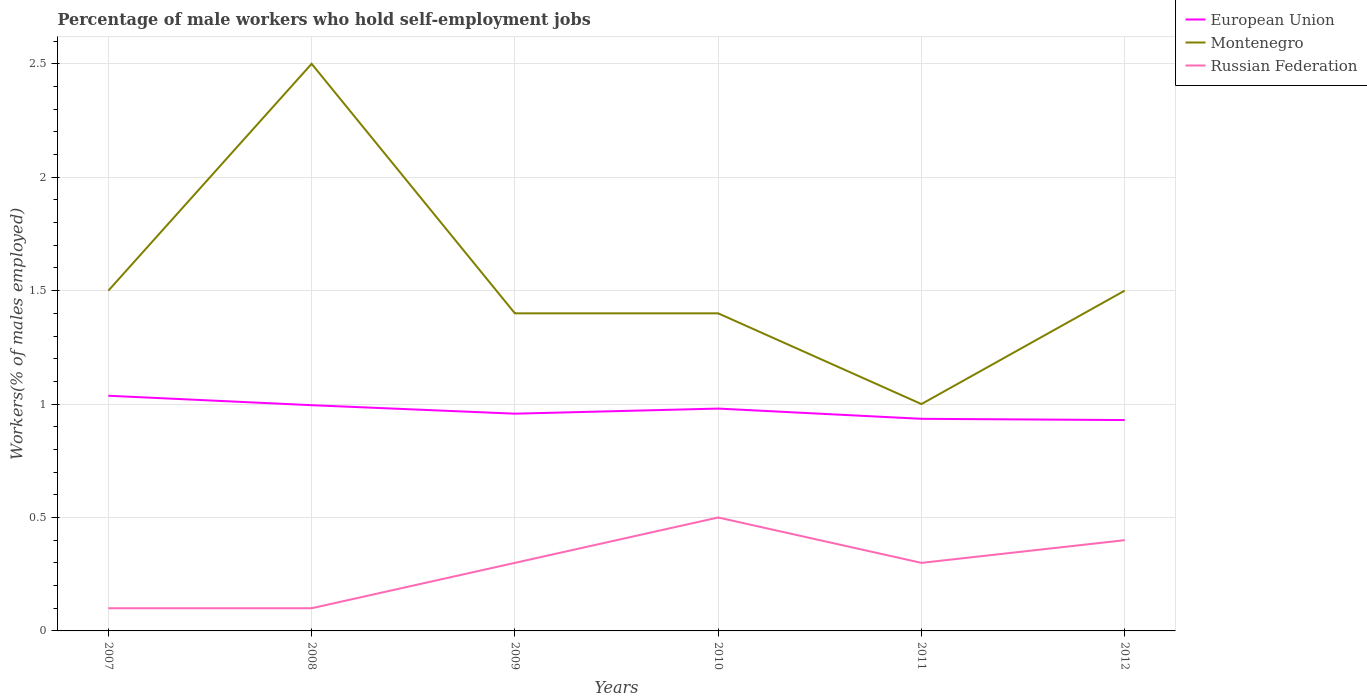How many different coloured lines are there?
Provide a succinct answer. 3. Is the number of lines equal to the number of legend labels?
Provide a short and direct response. Yes. Across all years, what is the maximum percentage of self-employed male workers in European Union?
Provide a succinct answer. 0.93. What is the total percentage of self-employed male workers in European Union in the graph?
Keep it short and to the point. 0.1. What is the difference between the highest and the second highest percentage of self-employed male workers in Russian Federation?
Offer a terse response. 0.4. What is the difference between the highest and the lowest percentage of self-employed male workers in European Union?
Offer a terse response. 3. How many lines are there?
Offer a terse response. 3. How many years are there in the graph?
Ensure brevity in your answer.  6. What is the difference between two consecutive major ticks on the Y-axis?
Ensure brevity in your answer.  0.5. Does the graph contain grids?
Keep it short and to the point. Yes. Where does the legend appear in the graph?
Keep it short and to the point. Top right. How many legend labels are there?
Provide a succinct answer. 3. What is the title of the graph?
Your answer should be very brief. Percentage of male workers who hold self-employment jobs. Does "Heavily indebted poor countries" appear as one of the legend labels in the graph?
Keep it short and to the point. No. What is the label or title of the Y-axis?
Your answer should be very brief. Workers(% of males employed). What is the Workers(% of males employed) in European Union in 2007?
Offer a terse response. 1.04. What is the Workers(% of males employed) of Montenegro in 2007?
Your answer should be very brief. 1.5. What is the Workers(% of males employed) in Russian Federation in 2007?
Provide a short and direct response. 0.1. What is the Workers(% of males employed) in European Union in 2008?
Give a very brief answer. 1. What is the Workers(% of males employed) of Russian Federation in 2008?
Offer a very short reply. 0.1. What is the Workers(% of males employed) in European Union in 2009?
Make the answer very short. 0.96. What is the Workers(% of males employed) in Montenegro in 2009?
Give a very brief answer. 1.4. What is the Workers(% of males employed) in Russian Federation in 2009?
Your response must be concise. 0.3. What is the Workers(% of males employed) of European Union in 2010?
Your answer should be compact. 0.98. What is the Workers(% of males employed) in Montenegro in 2010?
Provide a succinct answer. 1.4. What is the Workers(% of males employed) of Russian Federation in 2010?
Your response must be concise. 0.5. What is the Workers(% of males employed) in European Union in 2011?
Provide a succinct answer. 0.94. What is the Workers(% of males employed) in Montenegro in 2011?
Ensure brevity in your answer.  1. What is the Workers(% of males employed) in Russian Federation in 2011?
Give a very brief answer. 0.3. What is the Workers(% of males employed) in European Union in 2012?
Keep it short and to the point. 0.93. What is the Workers(% of males employed) of Montenegro in 2012?
Keep it short and to the point. 1.5. What is the Workers(% of males employed) in Russian Federation in 2012?
Give a very brief answer. 0.4. Across all years, what is the maximum Workers(% of males employed) in European Union?
Provide a succinct answer. 1.04. Across all years, what is the maximum Workers(% of males employed) of Russian Federation?
Provide a short and direct response. 0.5. Across all years, what is the minimum Workers(% of males employed) in European Union?
Your answer should be very brief. 0.93. Across all years, what is the minimum Workers(% of males employed) of Russian Federation?
Your answer should be very brief. 0.1. What is the total Workers(% of males employed) in European Union in the graph?
Your answer should be compact. 5.83. What is the total Workers(% of males employed) in Montenegro in the graph?
Provide a short and direct response. 9.3. What is the total Workers(% of males employed) of Russian Federation in the graph?
Give a very brief answer. 1.7. What is the difference between the Workers(% of males employed) in European Union in 2007 and that in 2008?
Keep it short and to the point. 0.04. What is the difference between the Workers(% of males employed) in Montenegro in 2007 and that in 2008?
Give a very brief answer. -1. What is the difference between the Workers(% of males employed) in Russian Federation in 2007 and that in 2008?
Your answer should be compact. 0. What is the difference between the Workers(% of males employed) in European Union in 2007 and that in 2009?
Give a very brief answer. 0.08. What is the difference between the Workers(% of males employed) of Montenegro in 2007 and that in 2009?
Offer a very short reply. 0.1. What is the difference between the Workers(% of males employed) in Russian Federation in 2007 and that in 2009?
Give a very brief answer. -0.2. What is the difference between the Workers(% of males employed) of European Union in 2007 and that in 2010?
Make the answer very short. 0.06. What is the difference between the Workers(% of males employed) of Russian Federation in 2007 and that in 2010?
Offer a very short reply. -0.4. What is the difference between the Workers(% of males employed) in European Union in 2007 and that in 2011?
Offer a very short reply. 0.1. What is the difference between the Workers(% of males employed) in European Union in 2007 and that in 2012?
Make the answer very short. 0.11. What is the difference between the Workers(% of males employed) of Montenegro in 2007 and that in 2012?
Offer a terse response. 0. What is the difference between the Workers(% of males employed) in Russian Federation in 2007 and that in 2012?
Give a very brief answer. -0.3. What is the difference between the Workers(% of males employed) of European Union in 2008 and that in 2009?
Make the answer very short. 0.04. What is the difference between the Workers(% of males employed) of Montenegro in 2008 and that in 2009?
Ensure brevity in your answer.  1.1. What is the difference between the Workers(% of males employed) in Russian Federation in 2008 and that in 2009?
Provide a succinct answer. -0.2. What is the difference between the Workers(% of males employed) of European Union in 2008 and that in 2010?
Your answer should be compact. 0.01. What is the difference between the Workers(% of males employed) of Montenegro in 2008 and that in 2010?
Offer a terse response. 1.1. What is the difference between the Workers(% of males employed) in European Union in 2008 and that in 2011?
Your answer should be compact. 0.06. What is the difference between the Workers(% of males employed) in Russian Federation in 2008 and that in 2011?
Provide a short and direct response. -0.2. What is the difference between the Workers(% of males employed) of European Union in 2008 and that in 2012?
Your response must be concise. 0.07. What is the difference between the Workers(% of males employed) of European Union in 2009 and that in 2010?
Offer a terse response. -0.02. What is the difference between the Workers(% of males employed) in Montenegro in 2009 and that in 2010?
Your response must be concise. 0. What is the difference between the Workers(% of males employed) of European Union in 2009 and that in 2011?
Your response must be concise. 0.02. What is the difference between the Workers(% of males employed) of Russian Federation in 2009 and that in 2011?
Give a very brief answer. 0. What is the difference between the Workers(% of males employed) in European Union in 2009 and that in 2012?
Your answer should be compact. 0.03. What is the difference between the Workers(% of males employed) of Montenegro in 2009 and that in 2012?
Your response must be concise. -0.1. What is the difference between the Workers(% of males employed) of European Union in 2010 and that in 2011?
Offer a very short reply. 0.05. What is the difference between the Workers(% of males employed) in Montenegro in 2010 and that in 2011?
Ensure brevity in your answer.  0.4. What is the difference between the Workers(% of males employed) in Russian Federation in 2010 and that in 2011?
Your answer should be compact. 0.2. What is the difference between the Workers(% of males employed) in European Union in 2010 and that in 2012?
Give a very brief answer. 0.05. What is the difference between the Workers(% of males employed) of Montenegro in 2010 and that in 2012?
Provide a short and direct response. -0.1. What is the difference between the Workers(% of males employed) in Russian Federation in 2010 and that in 2012?
Offer a terse response. 0.1. What is the difference between the Workers(% of males employed) in European Union in 2011 and that in 2012?
Offer a very short reply. 0.01. What is the difference between the Workers(% of males employed) of European Union in 2007 and the Workers(% of males employed) of Montenegro in 2008?
Your answer should be very brief. -1.46. What is the difference between the Workers(% of males employed) in European Union in 2007 and the Workers(% of males employed) in Russian Federation in 2008?
Keep it short and to the point. 0.94. What is the difference between the Workers(% of males employed) of European Union in 2007 and the Workers(% of males employed) of Montenegro in 2009?
Give a very brief answer. -0.36. What is the difference between the Workers(% of males employed) of European Union in 2007 and the Workers(% of males employed) of Russian Federation in 2009?
Ensure brevity in your answer.  0.74. What is the difference between the Workers(% of males employed) of European Union in 2007 and the Workers(% of males employed) of Montenegro in 2010?
Ensure brevity in your answer.  -0.36. What is the difference between the Workers(% of males employed) of European Union in 2007 and the Workers(% of males employed) of Russian Federation in 2010?
Make the answer very short. 0.54. What is the difference between the Workers(% of males employed) in European Union in 2007 and the Workers(% of males employed) in Montenegro in 2011?
Provide a succinct answer. 0.04. What is the difference between the Workers(% of males employed) in European Union in 2007 and the Workers(% of males employed) in Russian Federation in 2011?
Keep it short and to the point. 0.74. What is the difference between the Workers(% of males employed) of European Union in 2007 and the Workers(% of males employed) of Montenegro in 2012?
Your answer should be very brief. -0.46. What is the difference between the Workers(% of males employed) in European Union in 2007 and the Workers(% of males employed) in Russian Federation in 2012?
Your answer should be compact. 0.64. What is the difference between the Workers(% of males employed) of European Union in 2008 and the Workers(% of males employed) of Montenegro in 2009?
Offer a very short reply. -0.4. What is the difference between the Workers(% of males employed) of European Union in 2008 and the Workers(% of males employed) of Russian Federation in 2009?
Provide a short and direct response. 0.7. What is the difference between the Workers(% of males employed) in Montenegro in 2008 and the Workers(% of males employed) in Russian Federation in 2009?
Your response must be concise. 2.2. What is the difference between the Workers(% of males employed) of European Union in 2008 and the Workers(% of males employed) of Montenegro in 2010?
Ensure brevity in your answer.  -0.4. What is the difference between the Workers(% of males employed) in European Union in 2008 and the Workers(% of males employed) in Russian Federation in 2010?
Provide a succinct answer. 0.5. What is the difference between the Workers(% of males employed) in Montenegro in 2008 and the Workers(% of males employed) in Russian Federation in 2010?
Offer a very short reply. 2. What is the difference between the Workers(% of males employed) in European Union in 2008 and the Workers(% of males employed) in Montenegro in 2011?
Ensure brevity in your answer.  -0. What is the difference between the Workers(% of males employed) of European Union in 2008 and the Workers(% of males employed) of Russian Federation in 2011?
Ensure brevity in your answer.  0.7. What is the difference between the Workers(% of males employed) in European Union in 2008 and the Workers(% of males employed) in Montenegro in 2012?
Your answer should be compact. -0.5. What is the difference between the Workers(% of males employed) of European Union in 2008 and the Workers(% of males employed) of Russian Federation in 2012?
Ensure brevity in your answer.  0.6. What is the difference between the Workers(% of males employed) in Montenegro in 2008 and the Workers(% of males employed) in Russian Federation in 2012?
Make the answer very short. 2.1. What is the difference between the Workers(% of males employed) in European Union in 2009 and the Workers(% of males employed) in Montenegro in 2010?
Offer a very short reply. -0.44. What is the difference between the Workers(% of males employed) of European Union in 2009 and the Workers(% of males employed) of Russian Federation in 2010?
Your answer should be very brief. 0.46. What is the difference between the Workers(% of males employed) of Montenegro in 2009 and the Workers(% of males employed) of Russian Federation in 2010?
Your answer should be very brief. 0.9. What is the difference between the Workers(% of males employed) in European Union in 2009 and the Workers(% of males employed) in Montenegro in 2011?
Provide a succinct answer. -0.04. What is the difference between the Workers(% of males employed) in European Union in 2009 and the Workers(% of males employed) in Russian Federation in 2011?
Offer a terse response. 0.66. What is the difference between the Workers(% of males employed) of European Union in 2009 and the Workers(% of males employed) of Montenegro in 2012?
Provide a succinct answer. -0.54. What is the difference between the Workers(% of males employed) in European Union in 2009 and the Workers(% of males employed) in Russian Federation in 2012?
Ensure brevity in your answer.  0.56. What is the difference between the Workers(% of males employed) in Montenegro in 2009 and the Workers(% of males employed) in Russian Federation in 2012?
Ensure brevity in your answer.  1. What is the difference between the Workers(% of males employed) in European Union in 2010 and the Workers(% of males employed) in Montenegro in 2011?
Offer a very short reply. -0.02. What is the difference between the Workers(% of males employed) of European Union in 2010 and the Workers(% of males employed) of Russian Federation in 2011?
Offer a very short reply. 0.68. What is the difference between the Workers(% of males employed) in Montenegro in 2010 and the Workers(% of males employed) in Russian Federation in 2011?
Keep it short and to the point. 1.1. What is the difference between the Workers(% of males employed) in European Union in 2010 and the Workers(% of males employed) in Montenegro in 2012?
Offer a very short reply. -0.52. What is the difference between the Workers(% of males employed) of European Union in 2010 and the Workers(% of males employed) of Russian Federation in 2012?
Offer a terse response. 0.58. What is the difference between the Workers(% of males employed) in European Union in 2011 and the Workers(% of males employed) in Montenegro in 2012?
Provide a short and direct response. -0.56. What is the difference between the Workers(% of males employed) of European Union in 2011 and the Workers(% of males employed) of Russian Federation in 2012?
Ensure brevity in your answer.  0.54. What is the average Workers(% of males employed) of European Union per year?
Make the answer very short. 0.97. What is the average Workers(% of males employed) of Montenegro per year?
Your answer should be very brief. 1.55. What is the average Workers(% of males employed) of Russian Federation per year?
Your response must be concise. 0.28. In the year 2007, what is the difference between the Workers(% of males employed) of European Union and Workers(% of males employed) of Montenegro?
Provide a succinct answer. -0.46. In the year 2007, what is the difference between the Workers(% of males employed) of European Union and Workers(% of males employed) of Russian Federation?
Ensure brevity in your answer.  0.94. In the year 2007, what is the difference between the Workers(% of males employed) in Montenegro and Workers(% of males employed) in Russian Federation?
Your response must be concise. 1.4. In the year 2008, what is the difference between the Workers(% of males employed) in European Union and Workers(% of males employed) in Montenegro?
Offer a very short reply. -1.5. In the year 2008, what is the difference between the Workers(% of males employed) of European Union and Workers(% of males employed) of Russian Federation?
Give a very brief answer. 0.9. In the year 2008, what is the difference between the Workers(% of males employed) of Montenegro and Workers(% of males employed) of Russian Federation?
Provide a succinct answer. 2.4. In the year 2009, what is the difference between the Workers(% of males employed) in European Union and Workers(% of males employed) in Montenegro?
Offer a very short reply. -0.44. In the year 2009, what is the difference between the Workers(% of males employed) of European Union and Workers(% of males employed) of Russian Federation?
Provide a short and direct response. 0.66. In the year 2010, what is the difference between the Workers(% of males employed) in European Union and Workers(% of males employed) in Montenegro?
Your answer should be compact. -0.42. In the year 2010, what is the difference between the Workers(% of males employed) of European Union and Workers(% of males employed) of Russian Federation?
Provide a short and direct response. 0.48. In the year 2010, what is the difference between the Workers(% of males employed) in Montenegro and Workers(% of males employed) in Russian Federation?
Provide a succinct answer. 0.9. In the year 2011, what is the difference between the Workers(% of males employed) of European Union and Workers(% of males employed) of Montenegro?
Offer a very short reply. -0.07. In the year 2011, what is the difference between the Workers(% of males employed) in European Union and Workers(% of males employed) in Russian Federation?
Keep it short and to the point. 0.64. In the year 2012, what is the difference between the Workers(% of males employed) in European Union and Workers(% of males employed) in Montenegro?
Offer a very short reply. -0.57. In the year 2012, what is the difference between the Workers(% of males employed) of European Union and Workers(% of males employed) of Russian Federation?
Provide a short and direct response. 0.53. In the year 2012, what is the difference between the Workers(% of males employed) in Montenegro and Workers(% of males employed) in Russian Federation?
Keep it short and to the point. 1.1. What is the ratio of the Workers(% of males employed) in European Union in 2007 to that in 2008?
Ensure brevity in your answer.  1.04. What is the ratio of the Workers(% of males employed) in Russian Federation in 2007 to that in 2008?
Your response must be concise. 1. What is the ratio of the Workers(% of males employed) in European Union in 2007 to that in 2009?
Make the answer very short. 1.08. What is the ratio of the Workers(% of males employed) in Montenegro in 2007 to that in 2009?
Make the answer very short. 1.07. What is the ratio of the Workers(% of males employed) of Russian Federation in 2007 to that in 2009?
Your response must be concise. 0.33. What is the ratio of the Workers(% of males employed) in European Union in 2007 to that in 2010?
Your answer should be compact. 1.06. What is the ratio of the Workers(% of males employed) in Montenegro in 2007 to that in 2010?
Offer a very short reply. 1.07. What is the ratio of the Workers(% of males employed) of Russian Federation in 2007 to that in 2010?
Provide a succinct answer. 0.2. What is the ratio of the Workers(% of males employed) of European Union in 2007 to that in 2011?
Ensure brevity in your answer.  1.11. What is the ratio of the Workers(% of males employed) in Russian Federation in 2007 to that in 2011?
Offer a very short reply. 0.33. What is the ratio of the Workers(% of males employed) of European Union in 2007 to that in 2012?
Your response must be concise. 1.12. What is the ratio of the Workers(% of males employed) of Russian Federation in 2007 to that in 2012?
Offer a very short reply. 0.25. What is the ratio of the Workers(% of males employed) of European Union in 2008 to that in 2009?
Your answer should be compact. 1.04. What is the ratio of the Workers(% of males employed) of Montenegro in 2008 to that in 2009?
Provide a short and direct response. 1.79. What is the ratio of the Workers(% of males employed) of European Union in 2008 to that in 2010?
Your answer should be compact. 1.02. What is the ratio of the Workers(% of males employed) of Montenegro in 2008 to that in 2010?
Keep it short and to the point. 1.79. What is the ratio of the Workers(% of males employed) of European Union in 2008 to that in 2011?
Your answer should be compact. 1.06. What is the ratio of the Workers(% of males employed) of European Union in 2008 to that in 2012?
Your response must be concise. 1.07. What is the ratio of the Workers(% of males employed) of Montenegro in 2008 to that in 2012?
Offer a very short reply. 1.67. What is the ratio of the Workers(% of males employed) of European Union in 2009 to that in 2010?
Offer a very short reply. 0.98. What is the ratio of the Workers(% of males employed) in Russian Federation in 2009 to that in 2010?
Your response must be concise. 0.6. What is the ratio of the Workers(% of males employed) in European Union in 2009 to that in 2011?
Ensure brevity in your answer.  1.02. What is the ratio of the Workers(% of males employed) in Montenegro in 2009 to that in 2011?
Provide a short and direct response. 1.4. What is the ratio of the Workers(% of males employed) of Russian Federation in 2009 to that in 2011?
Make the answer very short. 1. What is the ratio of the Workers(% of males employed) in European Union in 2009 to that in 2012?
Keep it short and to the point. 1.03. What is the ratio of the Workers(% of males employed) of Montenegro in 2009 to that in 2012?
Keep it short and to the point. 0.93. What is the ratio of the Workers(% of males employed) of Russian Federation in 2009 to that in 2012?
Make the answer very short. 0.75. What is the ratio of the Workers(% of males employed) in European Union in 2010 to that in 2011?
Keep it short and to the point. 1.05. What is the ratio of the Workers(% of males employed) of Russian Federation in 2010 to that in 2011?
Your answer should be compact. 1.67. What is the ratio of the Workers(% of males employed) in European Union in 2010 to that in 2012?
Give a very brief answer. 1.05. What is the ratio of the Workers(% of males employed) of Montenegro in 2010 to that in 2012?
Your answer should be compact. 0.93. What is the ratio of the Workers(% of males employed) of Russian Federation in 2010 to that in 2012?
Provide a succinct answer. 1.25. What is the ratio of the Workers(% of males employed) of Montenegro in 2011 to that in 2012?
Give a very brief answer. 0.67. What is the ratio of the Workers(% of males employed) of Russian Federation in 2011 to that in 2012?
Make the answer very short. 0.75. What is the difference between the highest and the second highest Workers(% of males employed) in European Union?
Ensure brevity in your answer.  0.04. What is the difference between the highest and the lowest Workers(% of males employed) of European Union?
Your answer should be compact. 0.11. What is the difference between the highest and the lowest Workers(% of males employed) in Montenegro?
Your answer should be very brief. 1.5. 